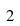Convert formula to latex. <formula><loc_0><loc_0><loc_500><loc_500>2</formula> 